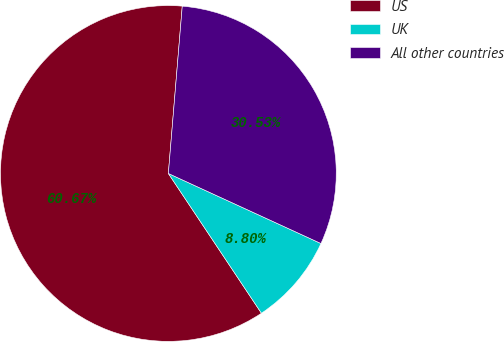<chart> <loc_0><loc_0><loc_500><loc_500><pie_chart><fcel>US<fcel>UK<fcel>All other countries<nl><fcel>60.67%<fcel>8.8%<fcel>30.53%<nl></chart> 